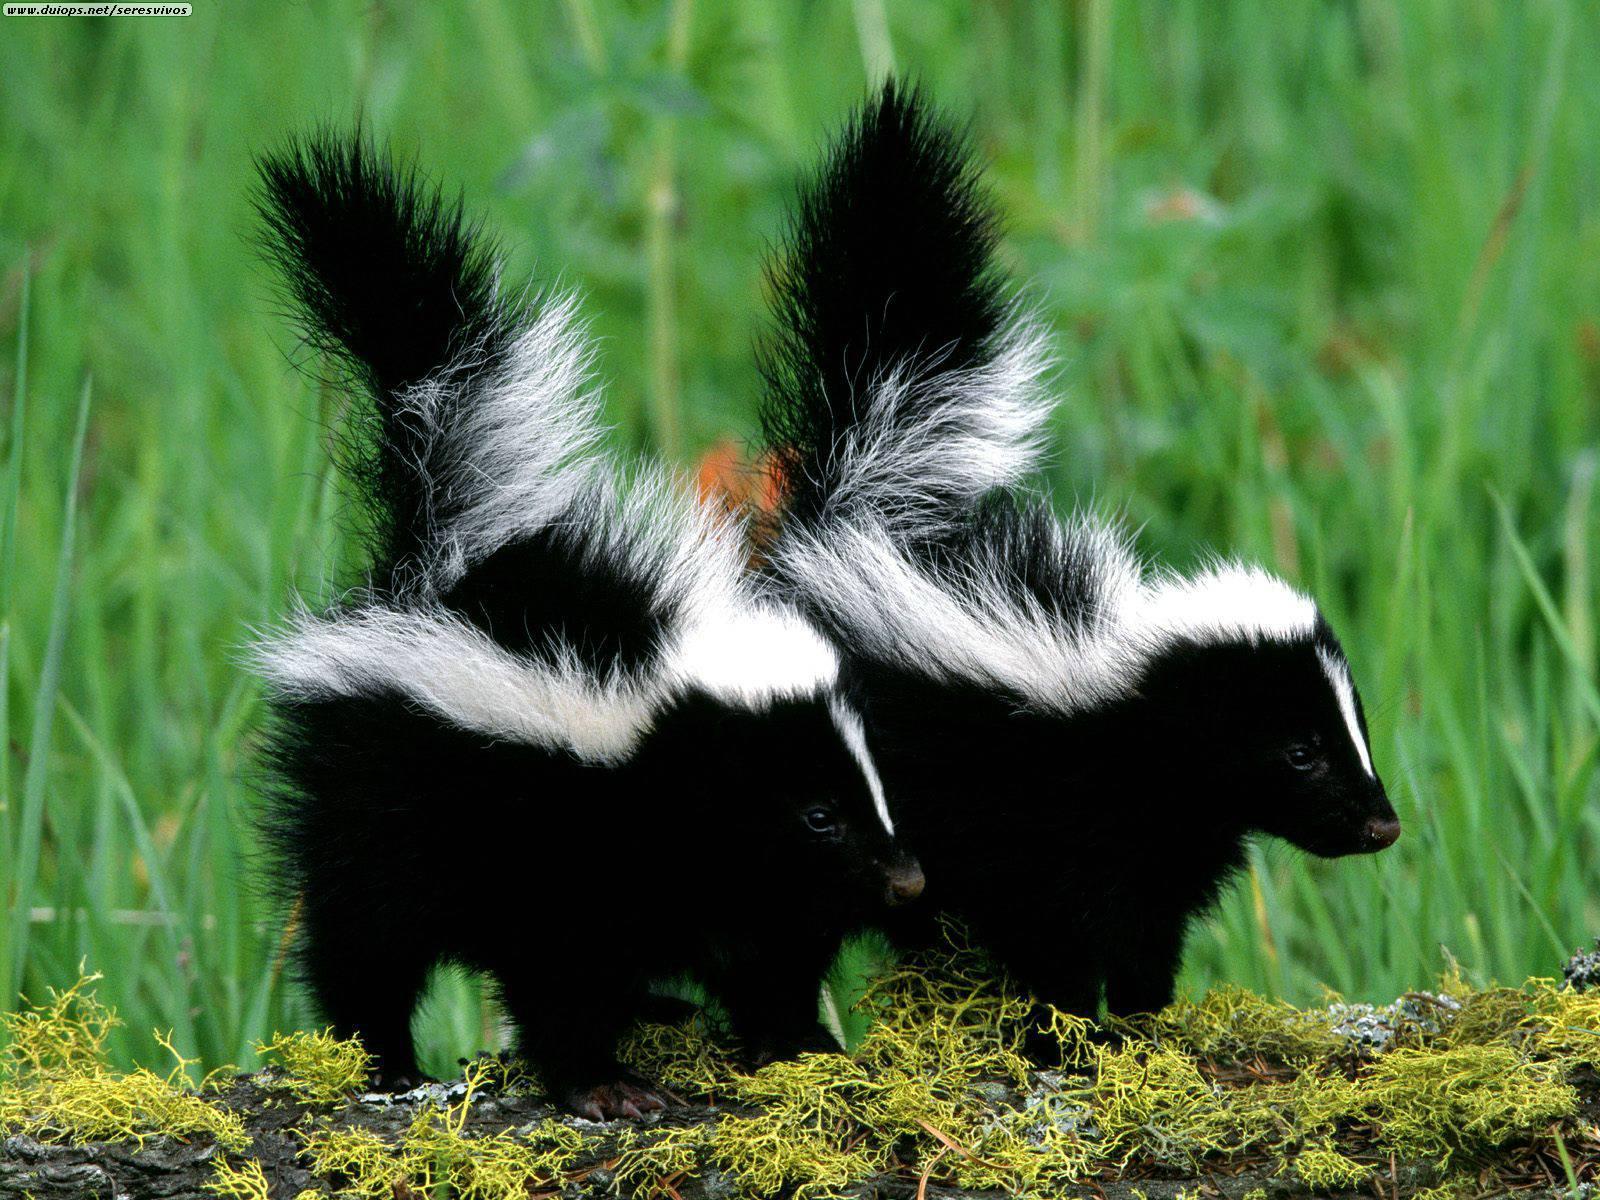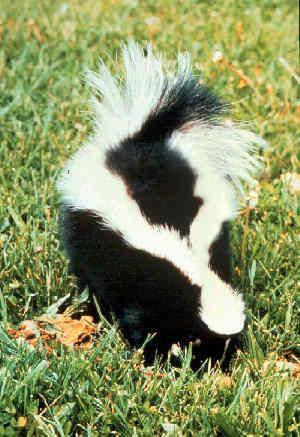The first image is the image on the left, the second image is the image on the right. Analyze the images presented: Is the assertion "There are three skunks in total." valid? Answer yes or no. Yes. The first image is the image on the left, the second image is the image on the right. For the images shown, is this caption "There are three skunks." true? Answer yes or no. Yes. 